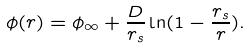Convert formula to latex. <formula><loc_0><loc_0><loc_500><loc_500>\phi ( r ) = \phi _ { \infty } + \frac { D } { r _ { s } } \ln ( 1 - \frac { r _ { s } } { r } ) .</formula> 